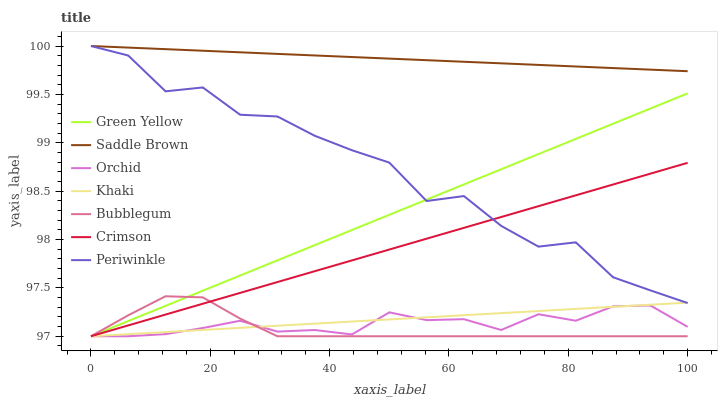Does Bubblegum have the minimum area under the curve?
Answer yes or no. Yes. Does Saddle Brown have the maximum area under the curve?
Answer yes or no. Yes. Does Periwinkle have the minimum area under the curve?
Answer yes or no. No. Does Periwinkle have the maximum area under the curve?
Answer yes or no. No. Is Saddle Brown the smoothest?
Answer yes or no. Yes. Is Periwinkle the roughest?
Answer yes or no. Yes. Is Bubblegum the smoothest?
Answer yes or no. No. Is Bubblegum the roughest?
Answer yes or no. No. Does Khaki have the lowest value?
Answer yes or no. Yes. Does Periwinkle have the lowest value?
Answer yes or no. No. Does Saddle Brown have the highest value?
Answer yes or no. Yes. Does Bubblegum have the highest value?
Answer yes or no. No. Is Khaki less than Saddle Brown?
Answer yes or no. Yes. Is Saddle Brown greater than Crimson?
Answer yes or no. Yes. Does Khaki intersect Orchid?
Answer yes or no. Yes. Is Khaki less than Orchid?
Answer yes or no. No. Is Khaki greater than Orchid?
Answer yes or no. No. Does Khaki intersect Saddle Brown?
Answer yes or no. No. 